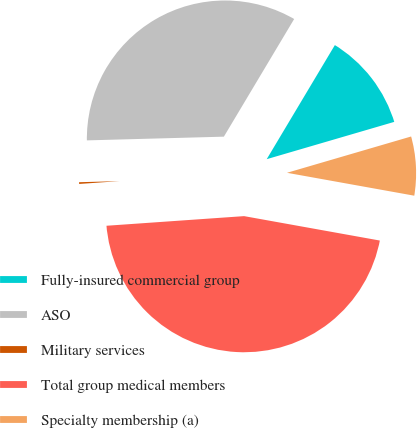Convert chart. <chart><loc_0><loc_0><loc_500><loc_500><pie_chart><fcel>Fully-insured commercial group<fcel>ASO<fcel>Military services<fcel>Total group medical members<fcel>Specialty membership (a)<nl><fcel>11.9%<fcel>34.0%<fcel>0.68%<fcel>46.05%<fcel>7.36%<nl></chart> 